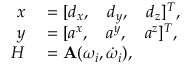Convert formula to latex. <formula><loc_0><loc_0><loc_500><loc_500>\begin{array} { r l } { x } & = [ d _ { x } , \quad d _ { y } , \quad d _ { z } ] ^ { T } , } \\ { y } & = [ a ^ { x } , \quad a ^ { y } , \quad a ^ { z } ] ^ { T } , } \\ { H } & = A ( \omega _ { i } , \dot { \omega } _ { i } ) , } \end{array}</formula> 